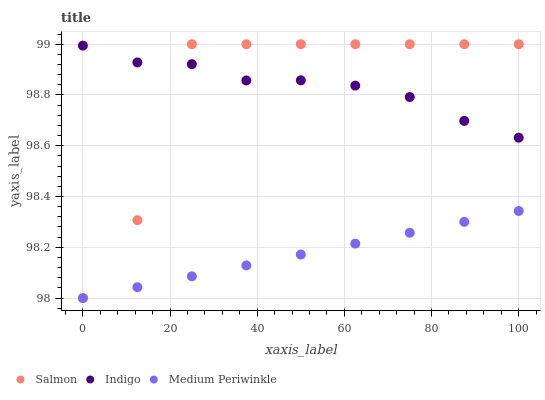Does Medium Periwinkle have the minimum area under the curve?
Answer yes or no. Yes. Does Salmon have the maximum area under the curve?
Answer yes or no. Yes. Does Salmon have the minimum area under the curve?
Answer yes or no. No. Does Medium Periwinkle have the maximum area under the curve?
Answer yes or no. No. Is Medium Periwinkle the smoothest?
Answer yes or no. Yes. Is Salmon the roughest?
Answer yes or no. Yes. Is Salmon the smoothest?
Answer yes or no. No. Is Medium Periwinkle the roughest?
Answer yes or no. No. Does Medium Periwinkle have the lowest value?
Answer yes or no. Yes. Does Salmon have the lowest value?
Answer yes or no. No. Does Salmon have the highest value?
Answer yes or no. Yes. Does Medium Periwinkle have the highest value?
Answer yes or no. No. Is Medium Periwinkle less than Indigo?
Answer yes or no. Yes. Is Indigo greater than Medium Periwinkle?
Answer yes or no. Yes. Does Salmon intersect Indigo?
Answer yes or no. Yes. Is Salmon less than Indigo?
Answer yes or no. No. Is Salmon greater than Indigo?
Answer yes or no. No. Does Medium Periwinkle intersect Indigo?
Answer yes or no. No. 